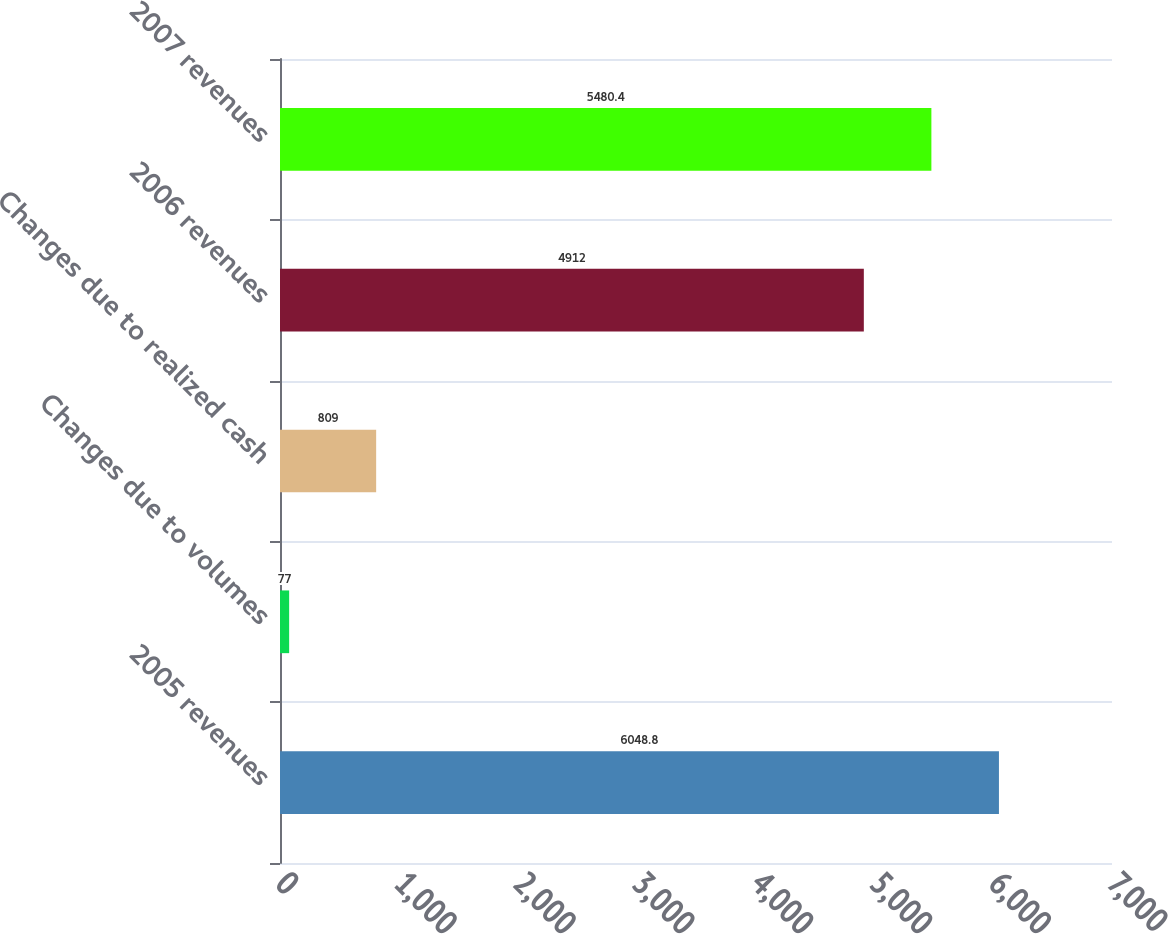<chart> <loc_0><loc_0><loc_500><loc_500><bar_chart><fcel>2005 revenues<fcel>Changes due to volumes<fcel>Changes due to realized cash<fcel>2006 revenues<fcel>2007 revenues<nl><fcel>6048.8<fcel>77<fcel>809<fcel>4912<fcel>5480.4<nl></chart> 